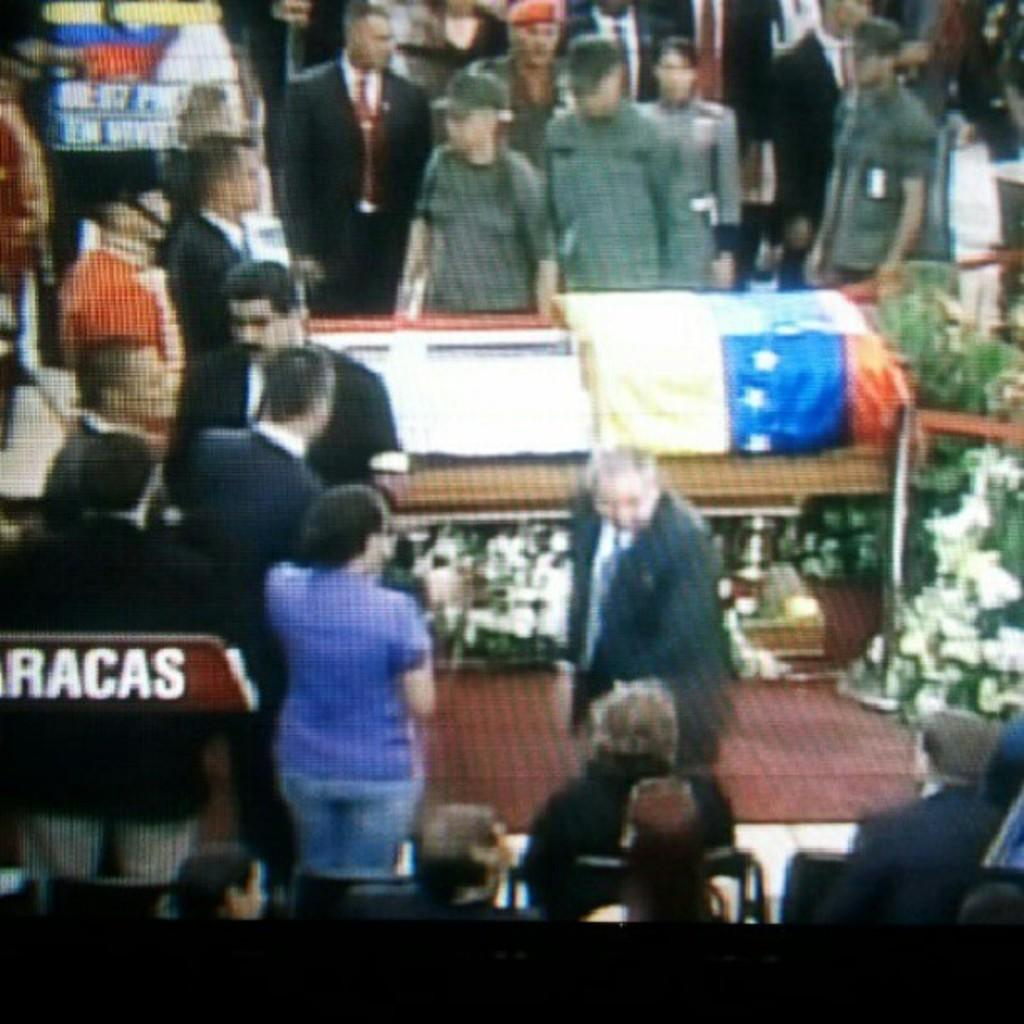What is the general activity of the people in the image? Some people are standing, and some are walking. What type of clothing can be seen on some of the people in the image? Some people are wearing blazers, ties, and shirts. Are there any other types of uniforms visible in the image? Yes, some people are wearing other uniforms. What type of stone can be seen in the image? There is no stone present in the image. What boundary is visible in the image? There is no boundary visible in the image. 